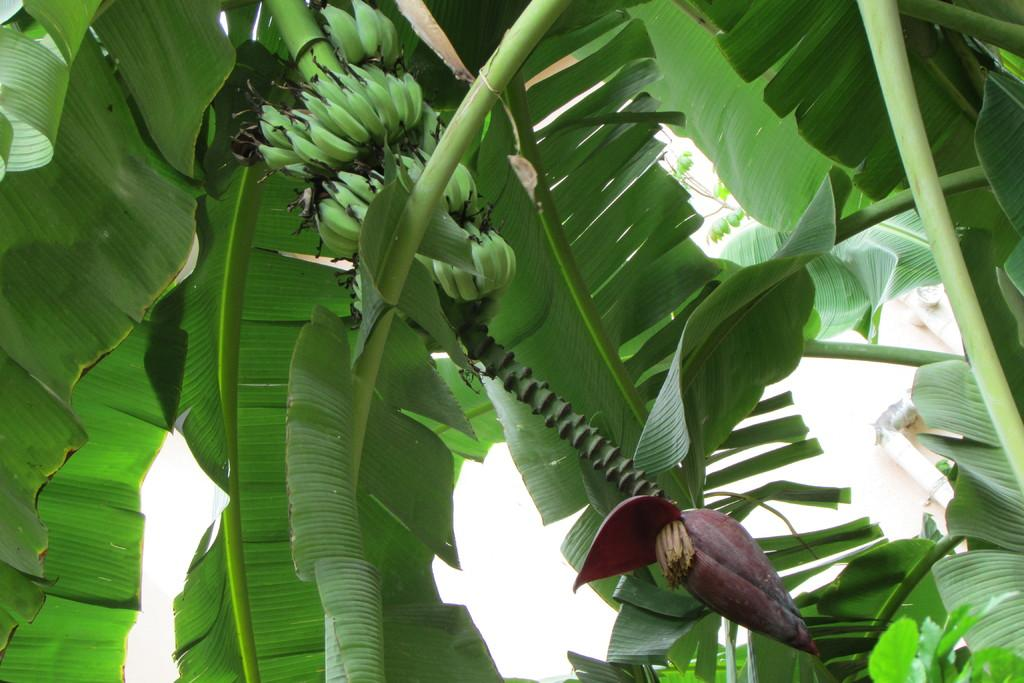What type of tree is present in the image? There is a banana tree in the image. What can be seen hanging from the tree? There are bananas visible on the tree. What else can be seen on the tree besides the bananas? There are leaves visible on the tree. What is visible in the background of the image? The sky is visible in the image. What is the price of the education being offered by the banana tree in the image? There is no education being offered by the banana tree in the image, and therefore no price can be determined. 